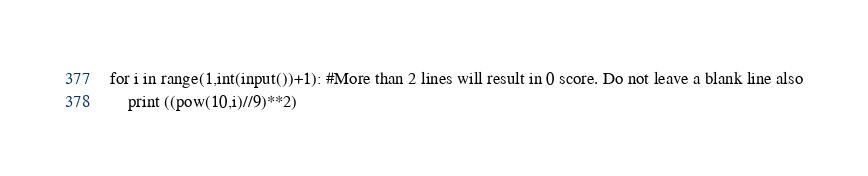Convert code to text. <code><loc_0><loc_0><loc_500><loc_500><_Python_>for i in range(1,int(input())+1): #More than 2 lines will result in 0 score. Do not leave a blank line also
    print ((pow(10,i)//9)**2)</code> 